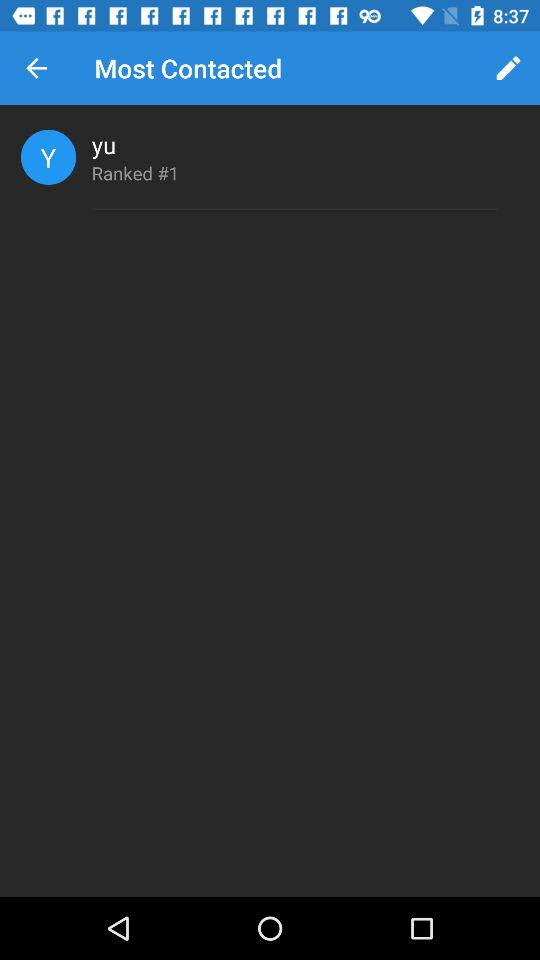What is the username? The username is "yu". 